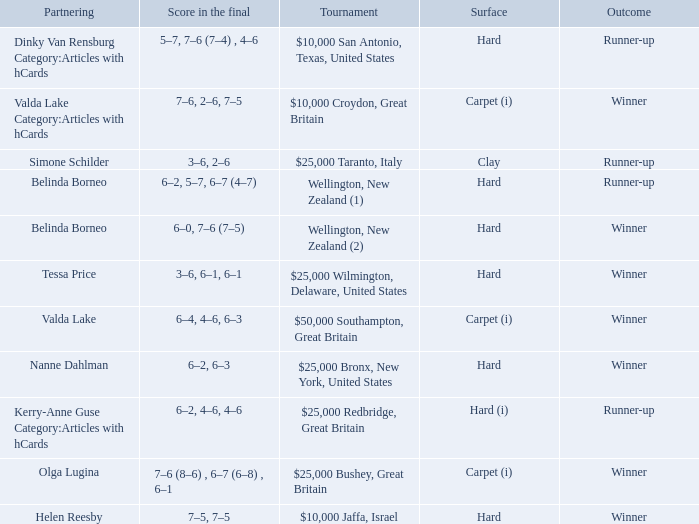What was the final score for the match with a partnering of Tessa Price? 3–6, 6–1, 6–1. 